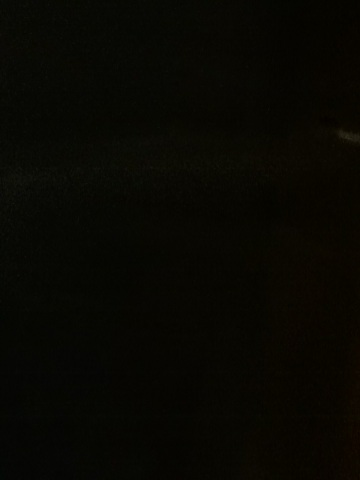What is the color of that phone? from Vizwiz unanswerable 